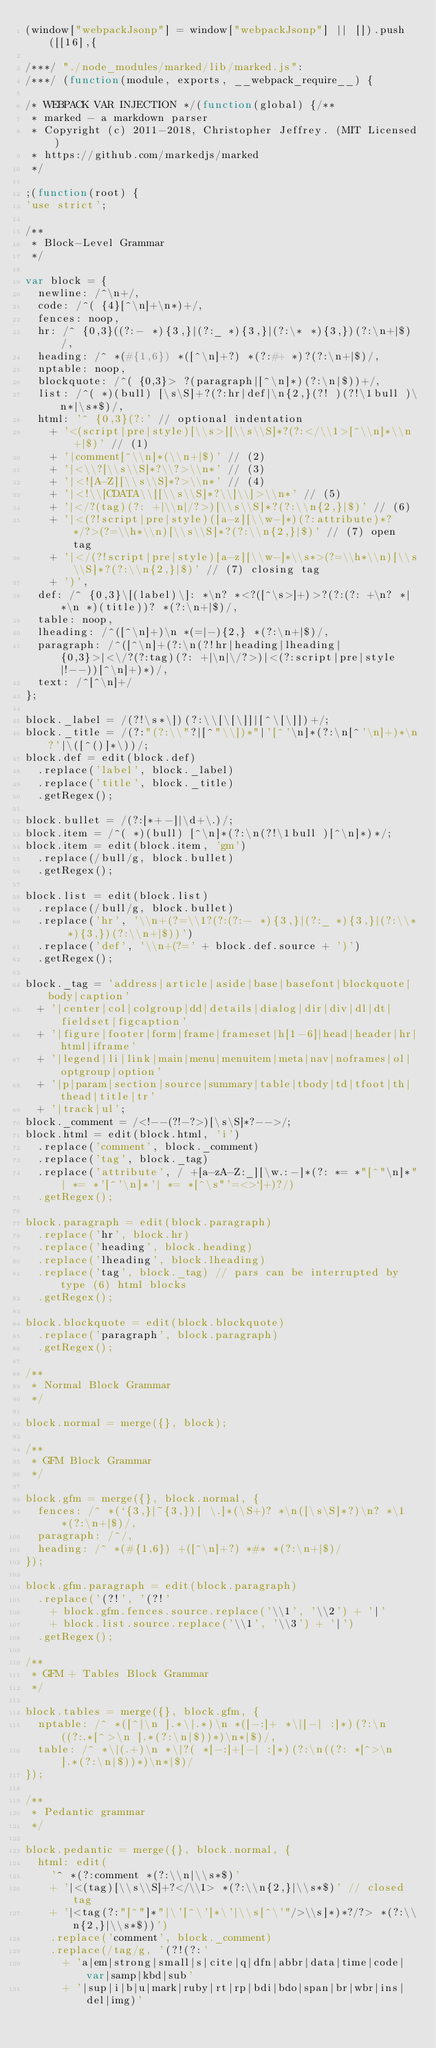Convert code to text. <code><loc_0><loc_0><loc_500><loc_500><_JavaScript_>(window["webpackJsonp"] = window["webpackJsonp"] || []).push([[16],{

/***/ "./node_modules/marked/lib/marked.js":
/***/ (function(module, exports, __webpack_require__) {

/* WEBPACK VAR INJECTION */(function(global) {/**
 * marked - a markdown parser
 * Copyright (c) 2011-2018, Christopher Jeffrey. (MIT Licensed)
 * https://github.com/markedjs/marked
 */

;(function(root) {
'use strict';

/**
 * Block-Level Grammar
 */

var block = {
  newline: /^\n+/,
  code: /^( {4}[^\n]+\n*)+/,
  fences: noop,
  hr: /^ {0,3}((?:- *){3,}|(?:_ *){3,}|(?:\* *){3,})(?:\n+|$)/,
  heading: /^ *(#{1,6}) *([^\n]+?) *(?:#+ *)?(?:\n+|$)/,
  nptable: noop,
  blockquote: /^( {0,3}> ?(paragraph|[^\n]*)(?:\n|$))+/,
  list: /^( *)(bull) [\s\S]+?(?:hr|def|\n{2,}(?! )(?!\1bull )\n*|\s*$)/,
  html: '^ {0,3}(?:' // optional indentation
    + '<(script|pre|style)[\\s>][\\s\\S]*?(?:</\\1>[^\\n]*\\n+|$)' // (1)
    + '|comment[^\\n]*(\\n+|$)' // (2)
    + '|<\\?[\\s\\S]*?\\?>\\n*' // (3)
    + '|<![A-Z][\\s\\S]*?>\\n*' // (4)
    + '|<!\\[CDATA\\[[\\s\\S]*?\\]\\]>\\n*' // (5)
    + '|</?(tag)(?: +|\\n|/?>)[\\s\\S]*?(?:\\n{2,}|$)' // (6)
    + '|<(?!script|pre|style)([a-z][\\w-]*)(?:attribute)*? */?>(?=\\h*\\n)[\\s\\S]*?(?:\\n{2,}|$)' // (7) open tag
    + '|</(?!script|pre|style)[a-z][\\w-]*\\s*>(?=\\h*\\n)[\\s\\S]*?(?:\\n{2,}|$)' // (7) closing tag
    + ')',
  def: /^ {0,3}\[(label)\]: *\n? *<?([^\s>]+)>?(?:(?: +\n? *| *\n *)(title))? *(?:\n+|$)/,
  table: noop,
  lheading: /^([^\n]+)\n *(=|-){2,} *(?:\n+|$)/,
  paragraph: /^([^\n]+(?:\n(?!hr|heading|lheading| {0,3}>|<\/?(?:tag)(?: +|\n|\/?>)|<(?:script|pre|style|!--))[^\n]+)*)/,
  text: /^[^\n]+/
};

block._label = /(?!\s*\])(?:\\[\[\]]|[^\[\]])+/;
block._title = /(?:"(?:\\"?|[^"\\])*"|'[^'\n]*(?:\n[^'\n]+)*\n?'|\([^()]*\))/;
block.def = edit(block.def)
  .replace('label', block._label)
  .replace('title', block._title)
  .getRegex();

block.bullet = /(?:[*+-]|\d+\.)/;
block.item = /^( *)(bull) [^\n]*(?:\n(?!\1bull )[^\n]*)*/;
block.item = edit(block.item, 'gm')
  .replace(/bull/g, block.bullet)
  .getRegex();

block.list = edit(block.list)
  .replace(/bull/g, block.bullet)
  .replace('hr', '\\n+(?=\\1?(?:(?:- *){3,}|(?:_ *){3,}|(?:\\* *){3,})(?:\\n+|$))')
  .replace('def', '\\n+(?=' + block.def.source + ')')
  .getRegex();

block._tag = 'address|article|aside|base|basefont|blockquote|body|caption'
  + '|center|col|colgroup|dd|details|dialog|dir|div|dl|dt|fieldset|figcaption'
  + '|figure|footer|form|frame|frameset|h[1-6]|head|header|hr|html|iframe'
  + '|legend|li|link|main|menu|menuitem|meta|nav|noframes|ol|optgroup|option'
  + '|p|param|section|source|summary|table|tbody|td|tfoot|th|thead|title|tr'
  + '|track|ul';
block._comment = /<!--(?!-?>)[\s\S]*?-->/;
block.html = edit(block.html, 'i')
  .replace('comment', block._comment)
  .replace('tag', block._tag)
  .replace('attribute', / +[a-zA-Z:_][\w.:-]*(?: *= *"[^"\n]*"| *= *'[^'\n]*'| *= *[^\s"'=<>`]+)?/)
  .getRegex();

block.paragraph = edit(block.paragraph)
  .replace('hr', block.hr)
  .replace('heading', block.heading)
  .replace('lheading', block.lheading)
  .replace('tag', block._tag) // pars can be interrupted by type (6) html blocks
  .getRegex();

block.blockquote = edit(block.blockquote)
  .replace('paragraph', block.paragraph)
  .getRegex();

/**
 * Normal Block Grammar
 */

block.normal = merge({}, block);

/**
 * GFM Block Grammar
 */

block.gfm = merge({}, block.normal, {
  fences: /^ *(`{3,}|~{3,})[ \.]*(\S+)? *\n([\s\S]*?)\n? *\1 *(?:\n+|$)/,
  paragraph: /^/,
  heading: /^ *(#{1,6}) +([^\n]+?) *#* *(?:\n+|$)/
});

block.gfm.paragraph = edit(block.paragraph)
  .replace('(?!', '(?!'
    + block.gfm.fences.source.replace('\\1', '\\2') + '|'
    + block.list.source.replace('\\1', '\\3') + '|')
  .getRegex();

/**
 * GFM + Tables Block Grammar
 */

block.tables = merge({}, block.gfm, {
  nptable: /^ *([^|\n ].*\|.*)\n *([-:]+ *\|[-| :]*)(?:\n((?:.*[^>\n ].*(?:\n|$))*)\n*|$)/,
  table: /^ *\|(.+)\n *\|?( *[-:]+[-| :]*)(?:\n((?: *[^>\n ].*(?:\n|$))*)\n*|$)/
});

/**
 * Pedantic grammar
 */

block.pedantic = merge({}, block.normal, {
  html: edit(
    '^ *(?:comment *(?:\\n|\\s*$)'
    + '|<(tag)[\\s\\S]+?</\\1> *(?:\\n{2,}|\\s*$)' // closed tag
    + '|<tag(?:"[^"]*"|\'[^\']*\'|\\s[^\'"/>\\s]*)*?/?> *(?:\\n{2,}|\\s*$))')
    .replace('comment', block._comment)
    .replace(/tag/g, '(?!(?:'
      + 'a|em|strong|small|s|cite|q|dfn|abbr|data|time|code|var|samp|kbd|sub'
      + '|sup|i|b|u|mark|ruby|rt|rp|bdi|bdo|span|br|wbr|ins|del|img)'</code> 